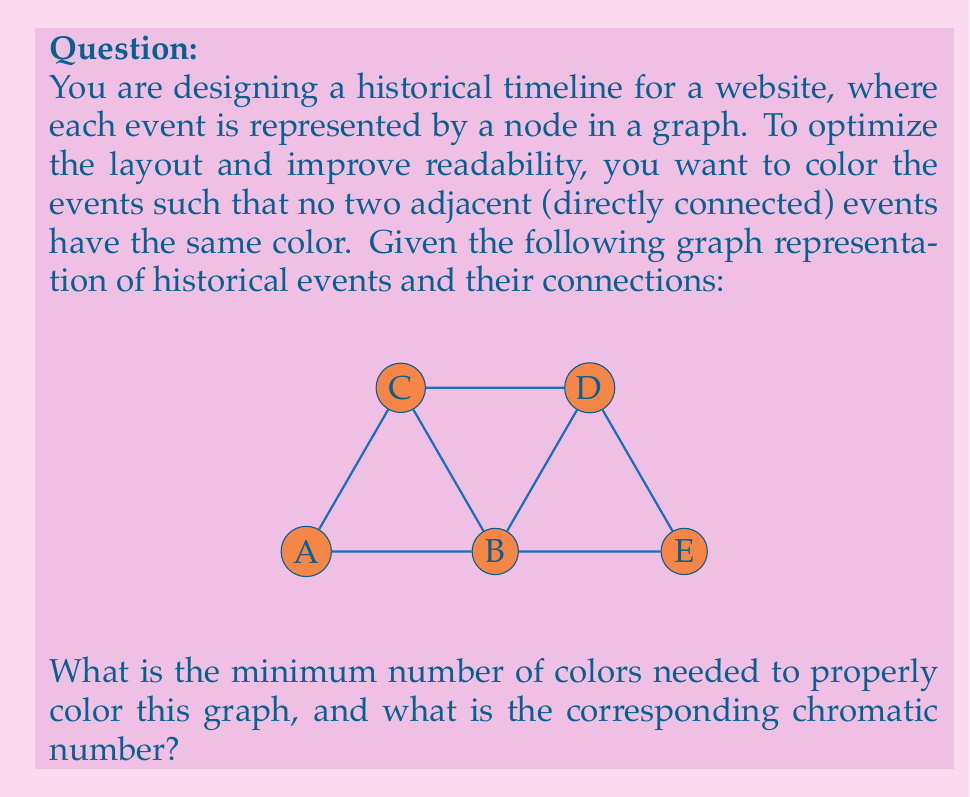Give your solution to this math problem. To solve this problem, we need to determine the chromatic number of the given graph. The chromatic number is the minimum number of colors required to color a graph such that no two adjacent vertices have the same color.

Let's approach this step-by-step:

1) First, we need to analyze the structure of the graph:
   - It has 5 vertices (A, B, C, D, E)
   - B is connected to all other vertices
   - A is connected to B and C
   - C is connected to A, B, and D
   - D is connected to B, C, and E
   - E is connected to B and D

2) We can start coloring the graph:
   - Assign color 1 to vertex A
   - B is adjacent to A, so it must have a different color. Assign color 2 to B
   - C is adjacent to both A and B, so it needs a third color. Assign color 3 to C
   - D is adjacent to B and C, but not A. We can use color 1 for D
   - E is adjacent to B and D, so we can use color 3 for E

3) After this coloring, we can verify that no two adjacent vertices have the same color.

4) We used a total of 3 colors in this coloring scheme.

5) To prove that this is indeed the minimum number of colors needed, we can observe that vertices A, B, and C form a triangle. In any graph containing a triangle, we always need at least 3 colors.

6) Since we have found a valid 3-coloring and proven that we can't use fewer than 3 colors, we can conclude that the chromatic number of this graph is 3.

The chromatic number is denoted by $\chi(G)$, where G is the graph. So in this case, $\chi(G) = 3$.
Answer: The minimum number of colors needed is 3, and the chromatic number $\chi(G) = 3$. 